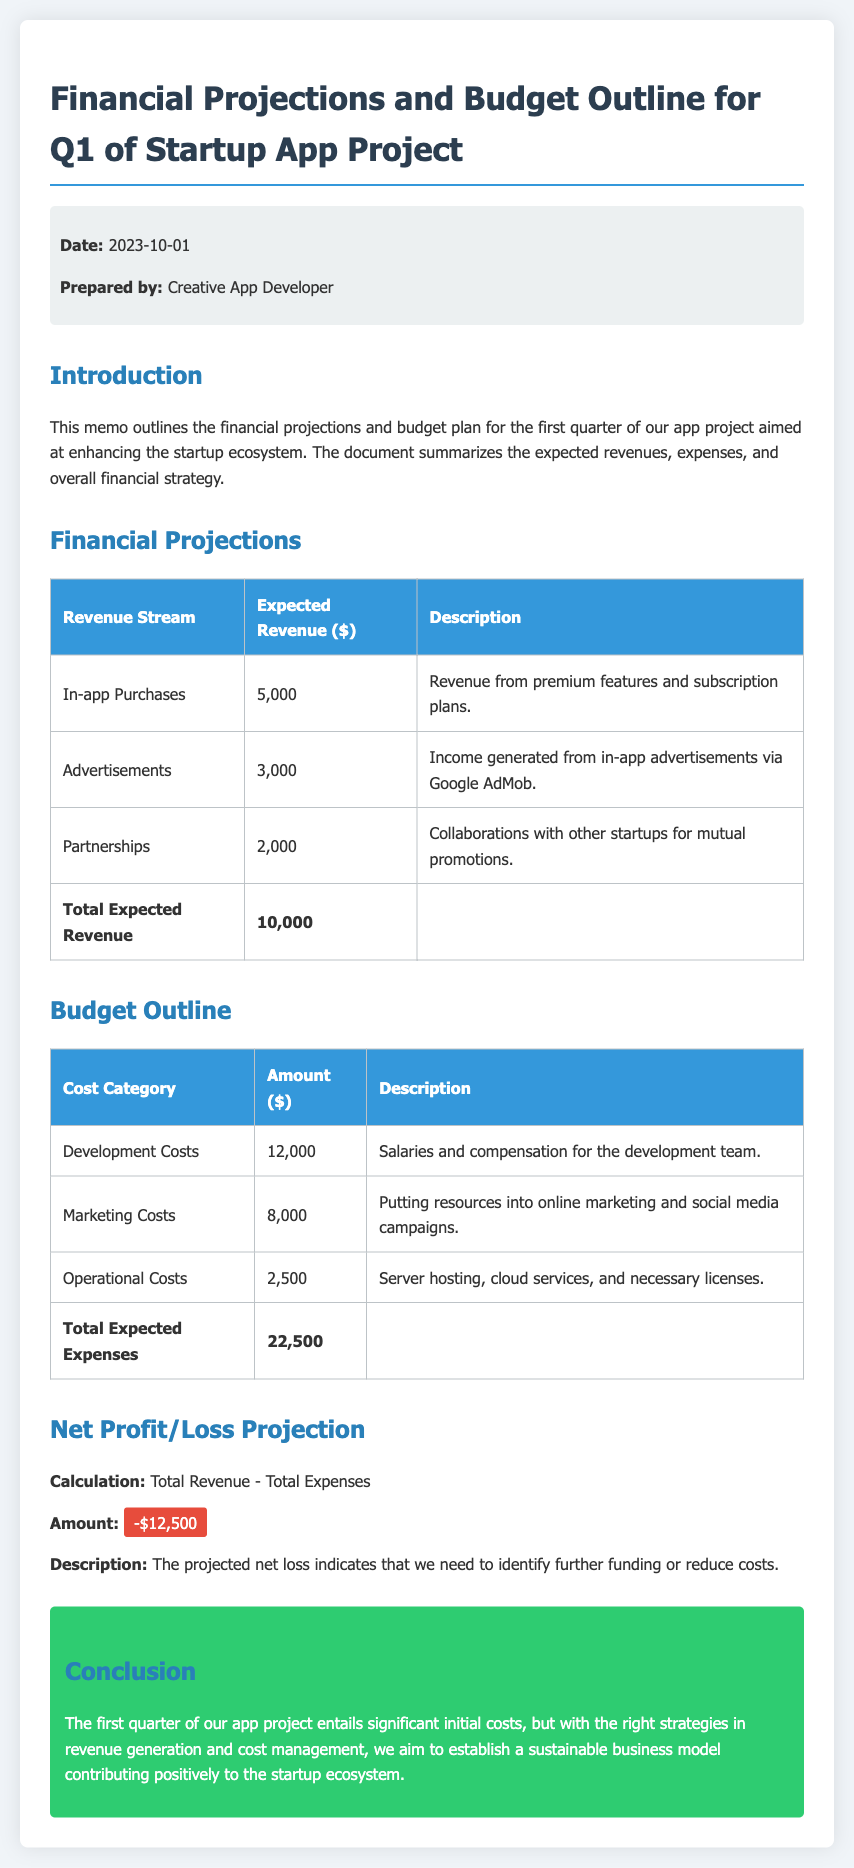What is the date of the memo? The date of the memo is stated at the top of the document.
Answer: 2023-10-01 Who prepared the memo? The prepared by section at the top reveals who created the document.
Answer: Creative App Developer What is the expected revenue from in-app purchases? The expected revenue from in-app purchases is provided in the financial projections section.
Answer: 5,000 What are the total expected expenses? The total expected expenses are the sum of all cost categories in the budget outline.
Answer: 22,500 What is the projected net profit/loss? The net profit/loss is calculated by subtracting total expenses from total revenue.
Answer: -12,500 What is the primary purpose of this memo? The introduction section outlines the purpose of the memo.
Answer: Financial projections and budget plan What category has the highest expense amount? The budget outline provides the cost categories and their respective amounts.
Answer: Development Costs What income source is expected to generate revenue from advertisements? The expected revenue from advertisements is listed under the financial projections section.
Answer: Google AdMob What type of costs does the operational costs category include? The description under operational costs gives context on what it entails.
Answer: Server hosting, cloud services, and necessary licenses 